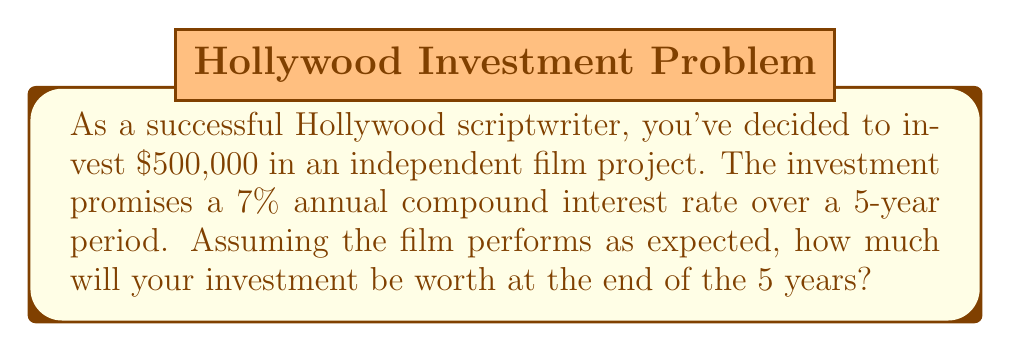Could you help me with this problem? To solve this problem, we'll use the compound interest formula:

$$A = P(1 + r)^t$$

Where:
$A$ = Final amount
$P$ = Principal (initial investment)
$r$ = Annual interest rate (as a decimal)
$t$ = Time in years

Given:
$P = \$500,000$
$r = 7\% = 0.07$
$t = 5$ years

Let's plug these values into the formula:

$$A = 500,000(1 + 0.07)^5$$

Now, let's calculate step-by-step:

1) First, add 1 to the interest rate:
   $1 + 0.07 = 1.07$

2) Now, raise this to the power of 5:
   $1.07^5 = 1.40255$ (rounded to 5 decimal places)

3) Finally, multiply by the principal:
   $500,000 \times 1.40255 = 701,275$

Therefore, the final amount after 5 years will be $701,275.
Answer: $701,275 